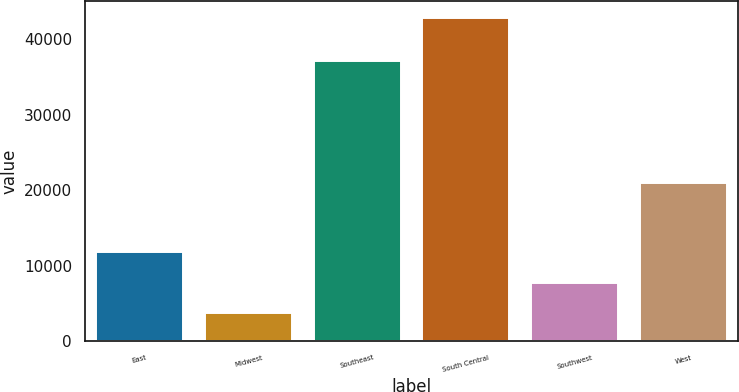<chart> <loc_0><loc_0><loc_500><loc_500><bar_chart><fcel>East<fcel>Midwest<fcel>Southeast<fcel>South Central<fcel>Southwest<fcel>West<nl><fcel>11900<fcel>3800<fcel>37100<fcel>42900<fcel>7710<fcel>21000<nl></chart> 